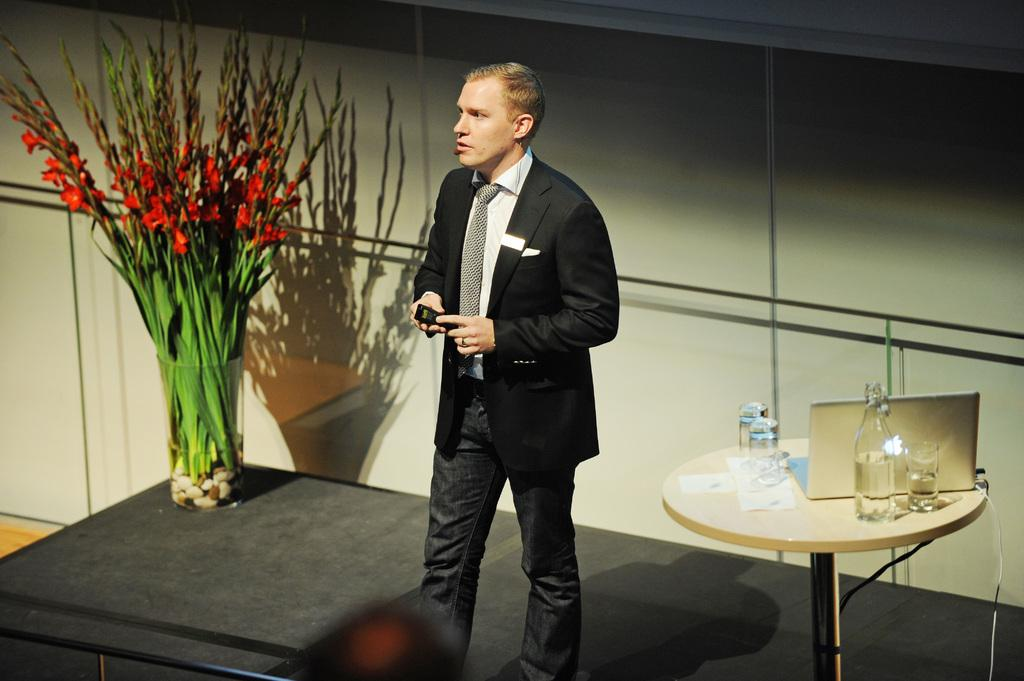What is the main subject in the image? There is a man standing in the image. What can be seen in the background of the image? There is a table in the image. What items are on the table? There are glasses, a bottle, and a laptop on the table. Is there any greenery present in the image? Yes, there is a plant in the image. What type of turkey is being discussed by the man in the image? There is no indication of a discussion or a turkey in the image; it primarily features a man standing near a table with various items. 